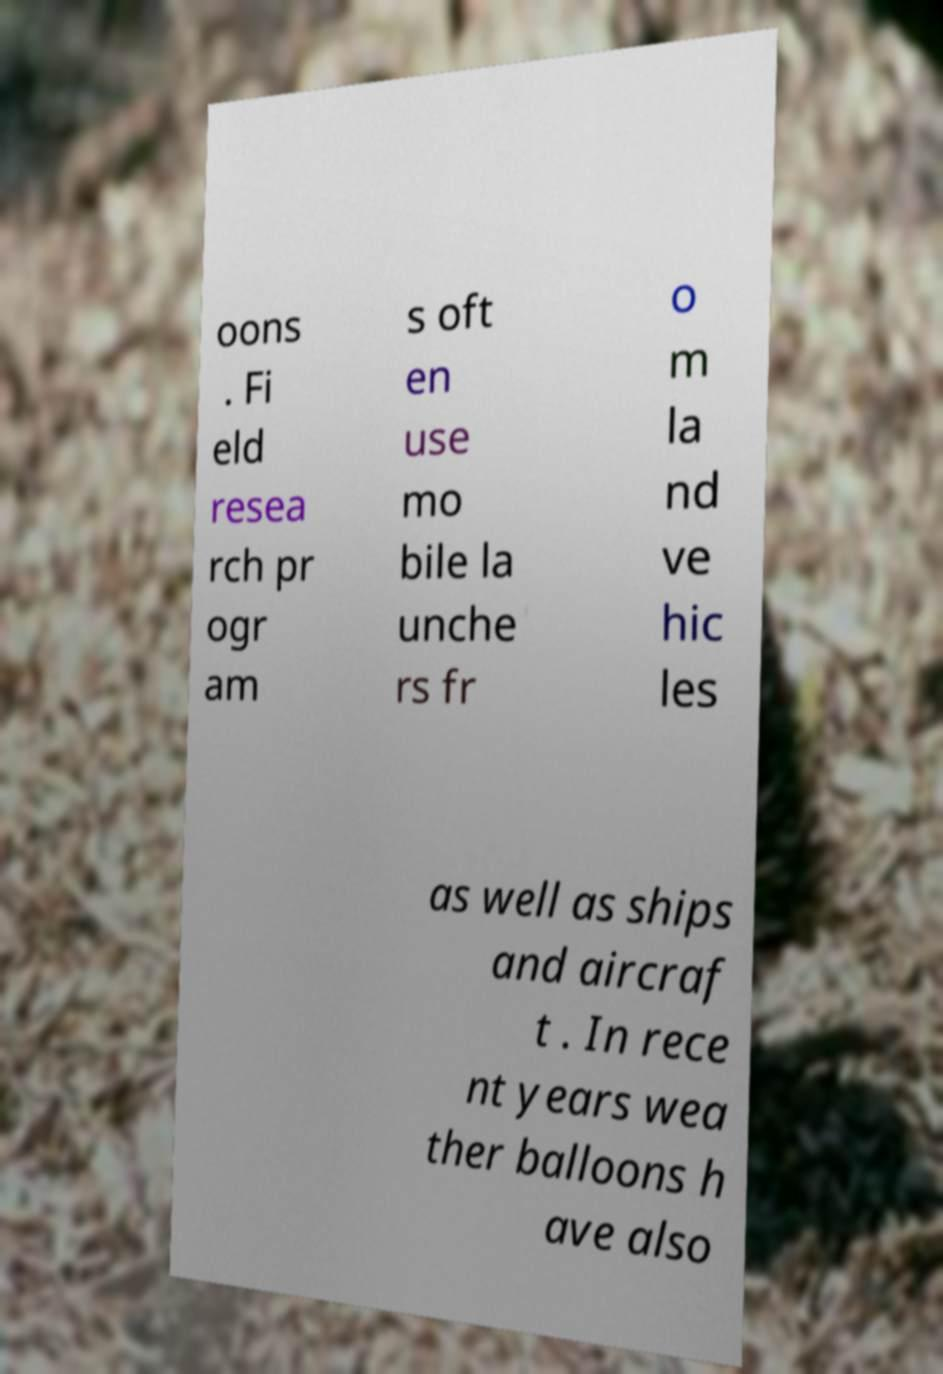Please identify and transcribe the text found in this image. oons . Fi eld resea rch pr ogr am s oft en use mo bile la unche rs fr o m la nd ve hic les as well as ships and aircraf t . In rece nt years wea ther balloons h ave also 